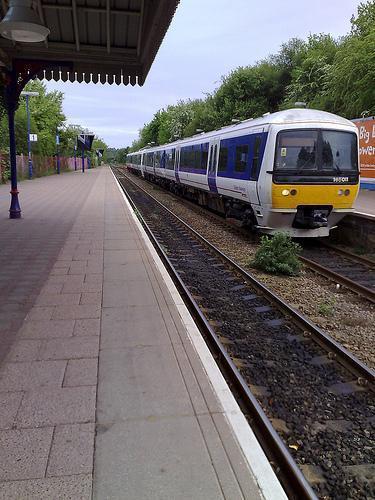How many trains are there?
Give a very brief answer. 1. 